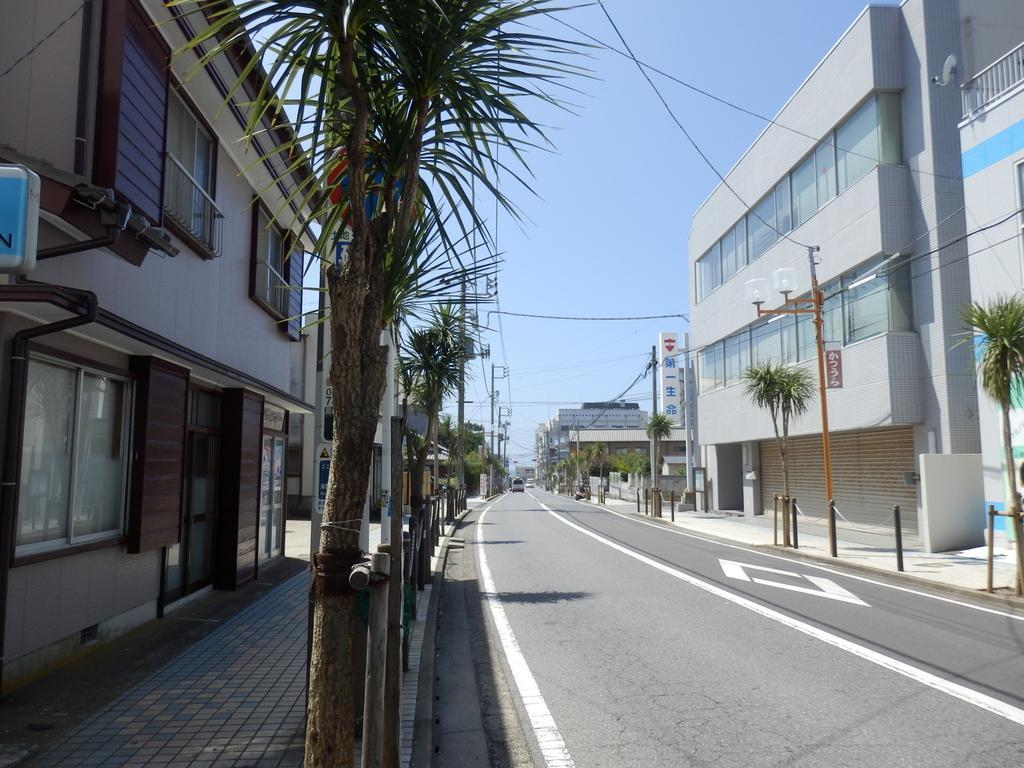Please provide a concise description of this image. In this image we can see road. To either side of the road we can see trees, buildings, windows, glass doors, fence and light poles. In the background there are trees, poles, buildings, wires and sky. 